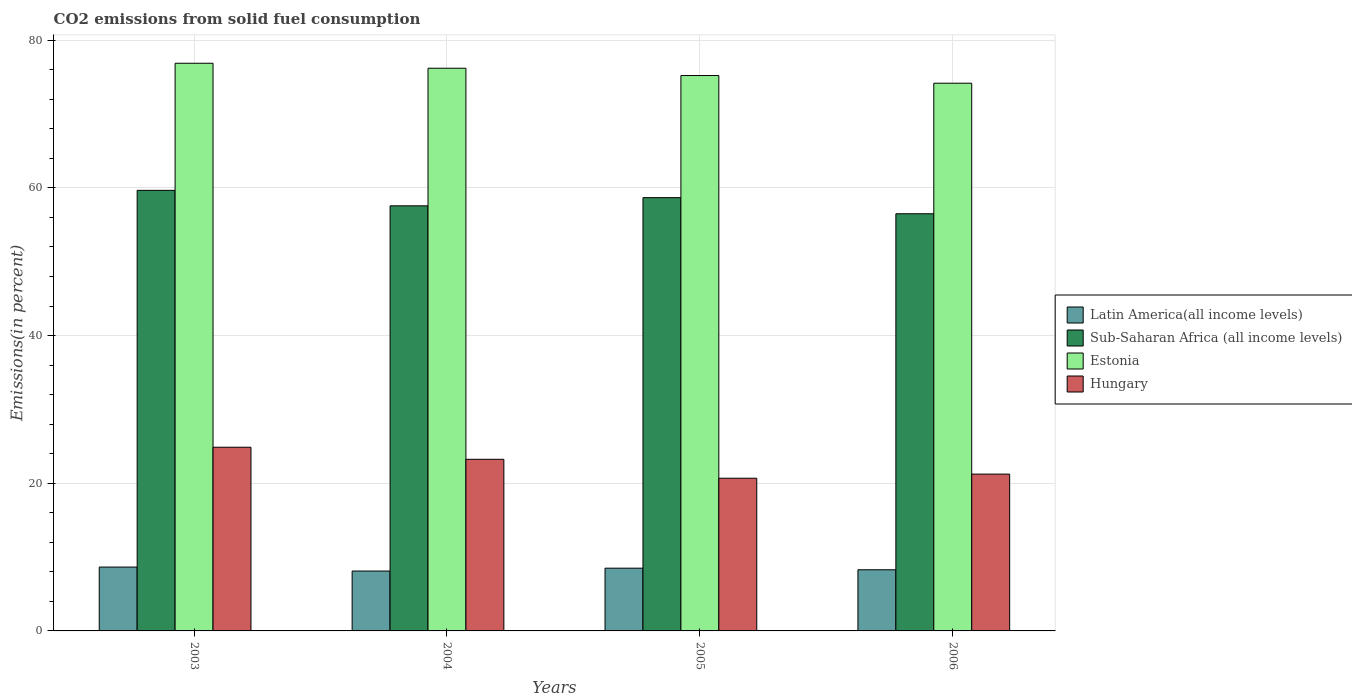How many bars are there on the 3rd tick from the right?
Offer a terse response. 4. What is the label of the 2nd group of bars from the left?
Provide a short and direct response. 2004. What is the total CO2 emitted in Hungary in 2006?
Give a very brief answer. 21.24. Across all years, what is the maximum total CO2 emitted in Estonia?
Provide a short and direct response. 76.88. Across all years, what is the minimum total CO2 emitted in Sub-Saharan Africa (all income levels)?
Keep it short and to the point. 56.5. In which year was the total CO2 emitted in Latin America(all income levels) maximum?
Offer a terse response. 2003. In which year was the total CO2 emitted in Latin America(all income levels) minimum?
Provide a succinct answer. 2004. What is the total total CO2 emitted in Estonia in the graph?
Your response must be concise. 302.49. What is the difference between the total CO2 emitted in Latin America(all income levels) in 2003 and that in 2006?
Offer a very short reply. 0.36. What is the difference between the total CO2 emitted in Hungary in 2006 and the total CO2 emitted in Estonia in 2004?
Keep it short and to the point. -54.97. What is the average total CO2 emitted in Estonia per year?
Provide a succinct answer. 75.62. In the year 2005, what is the difference between the total CO2 emitted in Latin America(all income levels) and total CO2 emitted in Estonia?
Make the answer very short. -66.72. What is the ratio of the total CO2 emitted in Sub-Saharan Africa (all income levels) in 2005 to that in 2006?
Provide a short and direct response. 1.04. Is the total CO2 emitted in Sub-Saharan Africa (all income levels) in 2003 less than that in 2004?
Provide a succinct answer. No. What is the difference between the highest and the second highest total CO2 emitted in Estonia?
Your response must be concise. 0.67. What is the difference between the highest and the lowest total CO2 emitted in Latin America(all income levels)?
Provide a succinct answer. 0.54. In how many years, is the total CO2 emitted in Latin America(all income levels) greater than the average total CO2 emitted in Latin America(all income levels) taken over all years?
Offer a terse response. 2. Is the sum of the total CO2 emitted in Estonia in 2003 and 2005 greater than the maximum total CO2 emitted in Sub-Saharan Africa (all income levels) across all years?
Your answer should be compact. Yes. Is it the case that in every year, the sum of the total CO2 emitted in Sub-Saharan Africa (all income levels) and total CO2 emitted in Hungary is greater than the sum of total CO2 emitted in Estonia and total CO2 emitted in Latin America(all income levels)?
Your answer should be compact. No. What does the 1st bar from the left in 2006 represents?
Your response must be concise. Latin America(all income levels). What does the 3rd bar from the right in 2003 represents?
Offer a terse response. Sub-Saharan Africa (all income levels). How many bars are there?
Offer a very short reply. 16. Are all the bars in the graph horizontal?
Offer a terse response. No. Are the values on the major ticks of Y-axis written in scientific E-notation?
Give a very brief answer. No. How many legend labels are there?
Make the answer very short. 4. What is the title of the graph?
Offer a very short reply. CO2 emissions from solid fuel consumption. What is the label or title of the Y-axis?
Keep it short and to the point. Emissions(in percent). What is the Emissions(in percent) in Latin America(all income levels) in 2003?
Make the answer very short. 8.65. What is the Emissions(in percent) in Sub-Saharan Africa (all income levels) in 2003?
Offer a very short reply. 59.67. What is the Emissions(in percent) of Estonia in 2003?
Ensure brevity in your answer.  76.88. What is the Emissions(in percent) in Hungary in 2003?
Your answer should be compact. 24.88. What is the Emissions(in percent) in Latin America(all income levels) in 2004?
Ensure brevity in your answer.  8.11. What is the Emissions(in percent) of Sub-Saharan Africa (all income levels) in 2004?
Your response must be concise. 57.57. What is the Emissions(in percent) of Estonia in 2004?
Provide a short and direct response. 76.21. What is the Emissions(in percent) of Hungary in 2004?
Offer a very short reply. 23.24. What is the Emissions(in percent) of Latin America(all income levels) in 2005?
Ensure brevity in your answer.  8.5. What is the Emissions(in percent) of Sub-Saharan Africa (all income levels) in 2005?
Your answer should be compact. 58.68. What is the Emissions(in percent) in Estonia in 2005?
Ensure brevity in your answer.  75.22. What is the Emissions(in percent) in Hungary in 2005?
Keep it short and to the point. 20.68. What is the Emissions(in percent) of Latin America(all income levels) in 2006?
Give a very brief answer. 8.28. What is the Emissions(in percent) of Sub-Saharan Africa (all income levels) in 2006?
Provide a short and direct response. 56.5. What is the Emissions(in percent) in Estonia in 2006?
Your answer should be compact. 74.18. What is the Emissions(in percent) in Hungary in 2006?
Keep it short and to the point. 21.24. Across all years, what is the maximum Emissions(in percent) of Latin America(all income levels)?
Your answer should be very brief. 8.65. Across all years, what is the maximum Emissions(in percent) of Sub-Saharan Africa (all income levels)?
Your answer should be very brief. 59.67. Across all years, what is the maximum Emissions(in percent) of Estonia?
Your answer should be compact. 76.88. Across all years, what is the maximum Emissions(in percent) of Hungary?
Provide a succinct answer. 24.88. Across all years, what is the minimum Emissions(in percent) of Latin America(all income levels)?
Your answer should be very brief. 8.11. Across all years, what is the minimum Emissions(in percent) of Sub-Saharan Africa (all income levels)?
Your response must be concise. 56.5. Across all years, what is the minimum Emissions(in percent) in Estonia?
Offer a terse response. 74.18. Across all years, what is the minimum Emissions(in percent) in Hungary?
Your answer should be compact. 20.68. What is the total Emissions(in percent) in Latin America(all income levels) in the graph?
Keep it short and to the point. 33.54. What is the total Emissions(in percent) in Sub-Saharan Africa (all income levels) in the graph?
Your answer should be very brief. 232.42. What is the total Emissions(in percent) in Estonia in the graph?
Provide a short and direct response. 302.49. What is the total Emissions(in percent) in Hungary in the graph?
Your answer should be very brief. 90.04. What is the difference between the Emissions(in percent) of Latin America(all income levels) in 2003 and that in 2004?
Give a very brief answer. 0.54. What is the difference between the Emissions(in percent) of Sub-Saharan Africa (all income levels) in 2003 and that in 2004?
Provide a succinct answer. 2.1. What is the difference between the Emissions(in percent) of Estonia in 2003 and that in 2004?
Make the answer very short. 0.67. What is the difference between the Emissions(in percent) of Hungary in 2003 and that in 2004?
Your response must be concise. 1.63. What is the difference between the Emissions(in percent) of Latin America(all income levels) in 2003 and that in 2005?
Keep it short and to the point. 0.15. What is the difference between the Emissions(in percent) in Estonia in 2003 and that in 2005?
Ensure brevity in your answer.  1.66. What is the difference between the Emissions(in percent) of Hungary in 2003 and that in 2005?
Your answer should be very brief. 4.2. What is the difference between the Emissions(in percent) of Latin America(all income levels) in 2003 and that in 2006?
Ensure brevity in your answer.  0.36. What is the difference between the Emissions(in percent) of Sub-Saharan Africa (all income levels) in 2003 and that in 2006?
Offer a very short reply. 3.17. What is the difference between the Emissions(in percent) in Estonia in 2003 and that in 2006?
Make the answer very short. 2.7. What is the difference between the Emissions(in percent) of Hungary in 2003 and that in 2006?
Provide a succinct answer. 3.64. What is the difference between the Emissions(in percent) of Latin America(all income levels) in 2004 and that in 2005?
Ensure brevity in your answer.  -0.39. What is the difference between the Emissions(in percent) in Sub-Saharan Africa (all income levels) in 2004 and that in 2005?
Your response must be concise. -1.11. What is the difference between the Emissions(in percent) in Estonia in 2004 and that in 2005?
Offer a terse response. 0.99. What is the difference between the Emissions(in percent) of Hungary in 2004 and that in 2005?
Make the answer very short. 2.56. What is the difference between the Emissions(in percent) of Latin America(all income levels) in 2004 and that in 2006?
Provide a short and direct response. -0.17. What is the difference between the Emissions(in percent) of Sub-Saharan Africa (all income levels) in 2004 and that in 2006?
Offer a terse response. 1.07. What is the difference between the Emissions(in percent) in Estonia in 2004 and that in 2006?
Ensure brevity in your answer.  2.03. What is the difference between the Emissions(in percent) in Hungary in 2004 and that in 2006?
Provide a short and direct response. 2. What is the difference between the Emissions(in percent) of Latin America(all income levels) in 2005 and that in 2006?
Ensure brevity in your answer.  0.22. What is the difference between the Emissions(in percent) of Sub-Saharan Africa (all income levels) in 2005 and that in 2006?
Keep it short and to the point. 2.18. What is the difference between the Emissions(in percent) in Estonia in 2005 and that in 2006?
Provide a short and direct response. 1.04. What is the difference between the Emissions(in percent) in Hungary in 2005 and that in 2006?
Offer a very short reply. -0.56. What is the difference between the Emissions(in percent) of Latin America(all income levels) in 2003 and the Emissions(in percent) of Sub-Saharan Africa (all income levels) in 2004?
Provide a short and direct response. -48.92. What is the difference between the Emissions(in percent) in Latin America(all income levels) in 2003 and the Emissions(in percent) in Estonia in 2004?
Offer a very short reply. -67.56. What is the difference between the Emissions(in percent) of Latin America(all income levels) in 2003 and the Emissions(in percent) of Hungary in 2004?
Make the answer very short. -14.6. What is the difference between the Emissions(in percent) of Sub-Saharan Africa (all income levels) in 2003 and the Emissions(in percent) of Estonia in 2004?
Make the answer very short. -16.54. What is the difference between the Emissions(in percent) in Sub-Saharan Africa (all income levels) in 2003 and the Emissions(in percent) in Hungary in 2004?
Offer a very short reply. 36.43. What is the difference between the Emissions(in percent) of Estonia in 2003 and the Emissions(in percent) of Hungary in 2004?
Provide a short and direct response. 53.64. What is the difference between the Emissions(in percent) in Latin America(all income levels) in 2003 and the Emissions(in percent) in Sub-Saharan Africa (all income levels) in 2005?
Keep it short and to the point. -50.03. What is the difference between the Emissions(in percent) of Latin America(all income levels) in 2003 and the Emissions(in percent) of Estonia in 2005?
Provide a short and direct response. -66.57. What is the difference between the Emissions(in percent) of Latin America(all income levels) in 2003 and the Emissions(in percent) of Hungary in 2005?
Give a very brief answer. -12.03. What is the difference between the Emissions(in percent) in Sub-Saharan Africa (all income levels) in 2003 and the Emissions(in percent) in Estonia in 2005?
Keep it short and to the point. -15.55. What is the difference between the Emissions(in percent) of Sub-Saharan Africa (all income levels) in 2003 and the Emissions(in percent) of Hungary in 2005?
Your response must be concise. 38.99. What is the difference between the Emissions(in percent) in Estonia in 2003 and the Emissions(in percent) in Hungary in 2005?
Offer a terse response. 56.2. What is the difference between the Emissions(in percent) in Latin America(all income levels) in 2003 and the Emissions(in percent) in Sub-Saharan Africa (all income levels) in 2006?
Give a very brief answer. -47.85. What is the difference between the Emissions(in percent) in Latin America(all income levels) in 2003 and the Emissions(in percent) in Estonia in 2006?
Your answer should be compact. -65.53. What is the difference between the Emissions(in percent) in Latin America(all income levels) in 2003 and the Emissions(in percent) in Hungary in 2006?
Your answer should be very brief. -12.59. What is the difference between the Emissions(in percent) of Sub-Saharan Africa (all income levels) in 2003 and the Emissions(in percent) of Estonia in 2006?
Make the answer very short. -14.51. What is the difference between the Emissions(in percent) of Sub-Saharan Africa (all income levels) in 2003 and the Emissions(in percent) of Hungary in 2006?
Your response must be concise. 38.43. What is the difference between the Emissions(in percent) in Estonia in 2003 and the Emissions(in percent) in Hungary in 2006?
Your response must be concise. 55.64. What is the difference between the Emissions(in percent) of Latin America(all income levels) in 2004 and the Emissions(in percent) of Sub-Saharan Africa (all income levels) in 2005?
Provide a short and direct response. -50.57. What is the difference between the Emissions(in percent) in Latin America(all income levels) in 2004 and the Emissions(in percent) in Estonia in 2005?
Provide a short and direct response. -67.11. What is the difference between the Emissions(in percent) of Latin America(all income levels) in 2004 and the Emissions(in percent) of Hungary in 2005?
Offer a very short reply. -12.57. What is the difference between the Emissions(in percent) in Sub-Saharan Africa (all income levels) in 2004 and the Emissions(in percent) in Estonia in 2005?
Your response must be concise. -17.65. What is the difference between the Emissions(in percent) in Sub-Saharan Africa (all income levels) in 2004 and the Emissions(in percent) in Hungary in 2005?
Ensure brevity in your answer.  36.89. What is the difference between the Emissions(in percent) in Estonia in 2004 and the Emissions(in percent) in Hungary in 2005?
Your answer should be very brief. 55.53. What is the difference between the Emissions(in percent) in Latin America(all income levels) in 2004 and the Emissions(in percent) in Sub-Saharan Africa (all income levels) in 2006?
Give a very brief answer. -48.39. What is the difference between the Emissions(in percent) of Latin America(all income levels) in 2004 and the Emissions(in percent) of Estonia in 2006?
Offer a very short reply. -66.07. What is the difference between the Emissions(in percent) of Latin America(all income levels) in 2004 and the Emissions(in percent) of Hungary in 2006?
Offer a terse response. -13.13. What is the difference between the Emissions(in percent) of Sub-Saharan Africa (all income levels) in 2004 and the Emissions(in percent) of Estonia in 2006?
Offer a terse response. -16.61. What is the difference between the Emissions(in percent) in Sub-Saharan Africa (all income levels) in 2004 and the Emissions(in percent) in Hungary in 2006?
Offer a very short reply. 36.33. What is the difference between the Emissions(in percent) of Estonia in 2004 and the Emissions(in percent) of Hungary in 2006?
Your answer should be compact. 54.97. What is the difference between the Emissions(in percent) of Latin America(all income levels) in 2005 and the Emissions(in percent) of Sub-Saharan Africa (all income levels) in 2006?
Your answer should be compact. -48. What is the difference between the Emissions(in percent) in Latin America(all income levels) in 2005 and the Emissions(in percent) in Estonia in 2006?
Ensure brevity in your answer.  -65.68. What is the difference between the Emissions(in percent) of Latin America(all income levels) in 2005 and the Emissions(in percent) of Hungary in 2006?
Keep it short and to the point. -12.74. What is the difference between the Emissions(in percent) in Sub-Saharan Africa (all income levels) in 2005 and the Emissions(in percent) in Estonia in 2006?
Give a very brief answer. -15.5. What is the difference between the Emissions(in percent) of Sub-Saharan Africa (all income levels) in 2005 and the Emissions(in percent) of Hungary in 2006?
Make the answer very short. 37.44. What is the difference between the Emissions(in percent) in Estonia in 2005 and the Emissions(in percent) in Hungary in 2006?
Ensure brevity in your answer.  53.98. What is the average Emissions(in percent) in Latin America(all income levels) per year?
Ensure brevity in your answer.  8.38. What is the average Emissions(in percent) in Sub-Saharan Africa (all income levels) per year?
Your answer should be compact. 58.1. What is the average Emissions(in percent) of Estonia per year?
Make the answer very short. 75.62. What is the average Emissions(in percent) of Hungary per year?
Your answer should be very brief. 22.51. In the year 2003, what is the difference between the Emissions(in percent) in Latin America(all income levels) and Emissions(in percent) in Sub-Saharan Africa (all income levels)?
Give a very brief answer. -51.02. In the year 2003, what is the difference between the Emissions(in percent) in Latin America(all income levels) and Emissions(in percent) in Estonia?
Provide a succinct answer. -68.23. In the year 2003, what is the difference between the Emissions(in percent) in Latin America(all income levels) and Emissions(in percent) in Hungary?
Your response must be concise. -16.23. In the year 2003, what is the difference between the Emissions(in percent) in Sub-Saharan Africa (all income levels) and Emissions(in percent) in Estonia?
Offer a very short reply. -17.21. In the year 2003, what is the difference between the Emissions(in percent) of Sub-Saharan Africa (all income levels) and Emissions(in percent) of Hungary?
Provide a short and direct response. 34.79. In the year 2003, what is the difference between the Emissions(in percent) of Estonia and Emissions(in percent) of Hungary?
Provide a succinct answer. 52. In the year 2004, what is the difference between the Emissions(in percent) in Latin America(all income levels) and Emissions(in percent) in Sub-Saharan Africa (all income levels)?
Provide a short and direct response. -49.46. In the year 2004, what is the difference between the Emissions(in percent) in Latin America(all income levels) and Emissions(in percent) in Estonia?
Make the answer very short. -68.1. In the year 2004, what is the difference between the Emissions(in percent) of Latin America(all income levels) and Emissions(in percent) of Hungary?
Give a very brief answer. -15.13. In the year 2004, what is the difference between the Emissions(in percent) in Sub-Saharan Africa (all income levels) and Emissions(in percent) in Estonia?
Ensure brevity in your answer.  -18.64. In the year 2004, what is the difference between the Emissions(in percent) in Sub-Saharan Africa (all income levels) and Emissions(in percent) in Hungary?
Ensure brevity in your answer.  34.33. In the year 2004, what is the difference between the Emissions(in percent) of Estonia and Emissions(in percent) of Hungary?
Your answer should be very brief. 52.97. In the year 2005, what is the difference between the Emissions(in percent) of Latin America(all income levels) and Emissions(in percent) of Sub-Saharan Africa (all income levels)?
Ensure brevity in your answer.  -50.18. In the year 2005, what is the difference between the Emissions(in percent) in Latin America(all income levels) and Emissions(in percent) in Estonia?
Your answer should be very brief. -66.72. In the year 2005, what is the difference between the Emissions(in percent) of Latin America(all income levels) and Emissions(in percent) of Hungary?
Make the answer very short. -12.18. In the year 2005, what is the difference between the Emissions(in percent) in Sub-Saharan Africa (all income levels) and Emissions(in percent) in Estonia?
Give a very brief answer. -16.54. In the year 2005, what is the difference between the Emissions(in percent) in Estonia and Emissions(in percent) in Hungary?
Make the answer very short. 54.54. In the year 2006, what is the difference between the Emissions(in percent) of Latin America(all income levels) and Emissions(in percent) of Sub-Saharan Africa (all income levels)?
Your answer should be compact. -48.22. In the year 2006, what is the difference between the Emissions(in percent) of Latin America(all income levels) and Emissions(in percent) of Estonia?
Offer a terse response. -65.9. In the year 2006, what is the difference between the Emissions(in percent) of Latin America(all income levels) and Emissions(in percent) of Hungary?
Ensure brevity in your answer.  -12.96. In the year 2006, what is the difference between the Emissions(in percent) in Sub-Saharan Africa (all income levels) and Emissions(in percent) in Estonia?
Offer a very short reply. -17.68. In the year 2006, what is the difference between the Emissions(in percent) of Sub-Saharan Africa (all income levels) and Emissions(in percent) of Hungary?
Keep it short and to the point. 35.26. In the year 2006, what is the difference between the Emissions(in percent) in Estonia and Emissions(in percent) in Hungary?
Your answer should be very brief. 52.94. What is the ratio of the Emissions(in percent) of Latin America(all income levels) in 2003 to that in 2004?
Provide a short and direct response. 1.07. What is the ratio of the Emissions(in percent) of Sub-Saharan Africa (all income levels) in 2003 to that in 2004?
Keep it short and to the point. 1.04. What is the ratio of the Emissions(in percent) in Estonia in 2003 to that in 2004?
Keep it short and to the point. 1.01. What is the ratio of the Emissions(in percent) in Hungary in 2003 to that in 2004?
Provide a short and direct response. 1.07. What is the ratio of the Emissions(in percent) of Latin America(all income levels) in 2003 to that in 2005?
Offer a very short reply. 1.02. What is the ratio of the Emissions(in percent) in Sub-Saharan Africa (all income levels) in 2003 to that in 2005?
Give a very brief answer. 1.02. What is the ratio of the Emissions(in percent) of Estonia in 2003 to that in 2005?
Your response must be concise. 1.02. What is the ratio of the Emissions(in percent) in Hungary in 2003 to that in 2005?
Offer a terse response. 1.2. What is the ratio of the Emissions(in percent) in Latin America(all income levels) in 2003 to that in 2006?
Keep it short and to the point. 1.04. What is the ratio of the Emissions(in percent) of Sub-Saharan Africa (all income levels) in 2003 to that in 2006?
Ensure brevity in your answer.  1.06. What is the ratio of the Emissions(in percent) in Estonia in 2003 to that in 2006?
Offer a terse response. 1.04. What is the ratio of the Emissions(in percent) of Hungary in 2003 to that in 2006?
Your response must be concise. 1.17. What is the ratio of the Emissions(in percent) in Latin America(all income levels) in 2004 to that in 2005?
Keep it short and to the point. 0.95. What is the ratio of the Emissions(in percent) in Sub-Saharan Africa (all income levels) in 2004 to that in 2005?
Provide a short and direct response. 0.98. What is the ratio of the Emissions(in percent) of Estonia in 2004 to that in 2005?
Your answer should be very brief. 1.01. What is the ratio of the Emissions(in percent) in Hungary in 2004 to that in 2005?
Your answer should be very brief. 1.12. What is the ratio of the Emissions(in percent) in Latin America(all income levels) in 2004 to that in 2006?
Your answer should be very brief. 0.98. What is the ratio of the Emissions(in percent) of Estonia in 2004 to that in 2006?
Provide a succinct answer. 1.03. What is the ratio of the Emissions(in percent) in Hungary in 2004 to that in 2006?
Your response must be concise. 1.09. What is the ratio of the Emissions(in percent) in Latin America(all income levels) in 2005 to that in 2006?
Your response must be concise. 1.03. What is the ratio of the Emissions(in percent) in Sub-Saharan Africa (all income levels) in 2005 to that in 2006?
Keep it short and to the point. 1.04. What is the ratio of the Emissions(in percent) in Hungary in 2005 to that in 2006?
Your answer should be compact. 0.97. What is the difference between the highest and the second highest Emissions(in percent) in Latin America(all income levels)?
Offer a very short reply. 0.15. What is the difference between the highest and the second highest Emissions(in percent) of Sub-Saharan Africa (all income levels)?
Provide a succinct answer. 0.99. What is the difference between the highest and the second highest Emissions(in percent) in Estonia?
Offer a very short reply. 0.67. What is the difference between the highest and the second highest Emissions(in percent) in Hungary?
Provide a succinct answer. 1.63. What is the difference between the highest and the lowest Emissions(in percent) of Latin America(all income levels)?
Keep it short and to the point. 0.54. What is the difference between the highest and the lowest Emissions(in percent) of Sub-Saharan Africa (all income levels)?
Your answer should be compact. 3.17. What is the difference between the highest and the lowest Emissions(in percent) of Estonia?
Your response must be concise. 2.7. What is the difference between the highest and the lowest Emissions(in percent) of Hungary?
Your response must be concise. 4.2. 